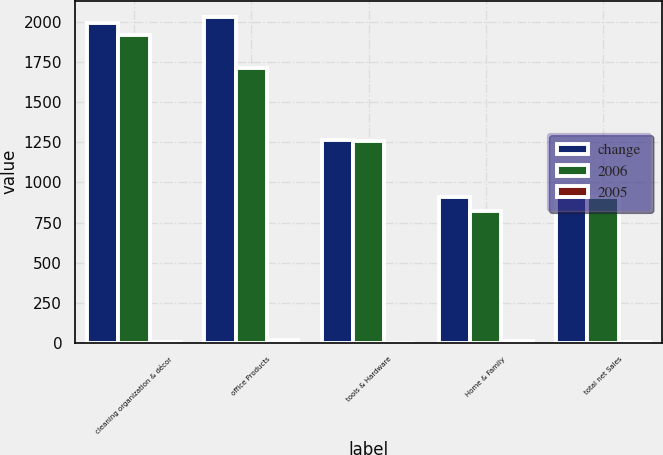Convert chart to OTSL. <chart><loc_0><loc_0><loc_500><loc_500><stacked_bar_chart><ecel><fcel>cleaning organization & décor<fcel>office Products<fcel>tools & Hardware<fcel>Home & Family<fcel>total net Sales<nl><fcel>change<fcel>1995.7<fcel>2031.6<fcel>1262.2<fcel>911.5<fcel>911.5<nl><fcel>2006<fcel>1921<fcel>1713.3<fcel>1260.3<fcel>822.6<fcel>911.5<nl><fcel>2005<fcel>3.9<fcel>18.6<fcel>0.2<fcel>10.8<fcel>8.5<nl></chart> 